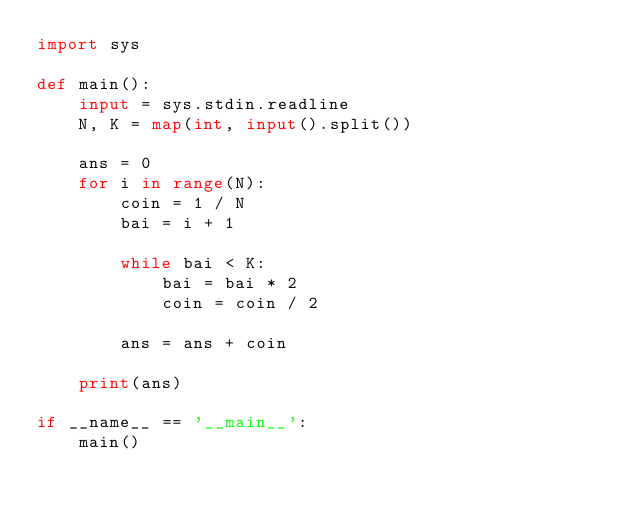<code> <loc_0><loc_0><loc_500><loc_500><_Python_>import sys

def main():
    input = sys.stdin.readline
    N, K = map(int, input().split())
    
    ans = 0
    for i in range(N):
        coin = 1 / N
        bai = i + 1
        
        while bai < K:
            bai = bai * 2
            coin = coin / 2
        
        ans = ans + coin
    
    print(ans)

if __name__ == '__main__':
    main()

</code> 